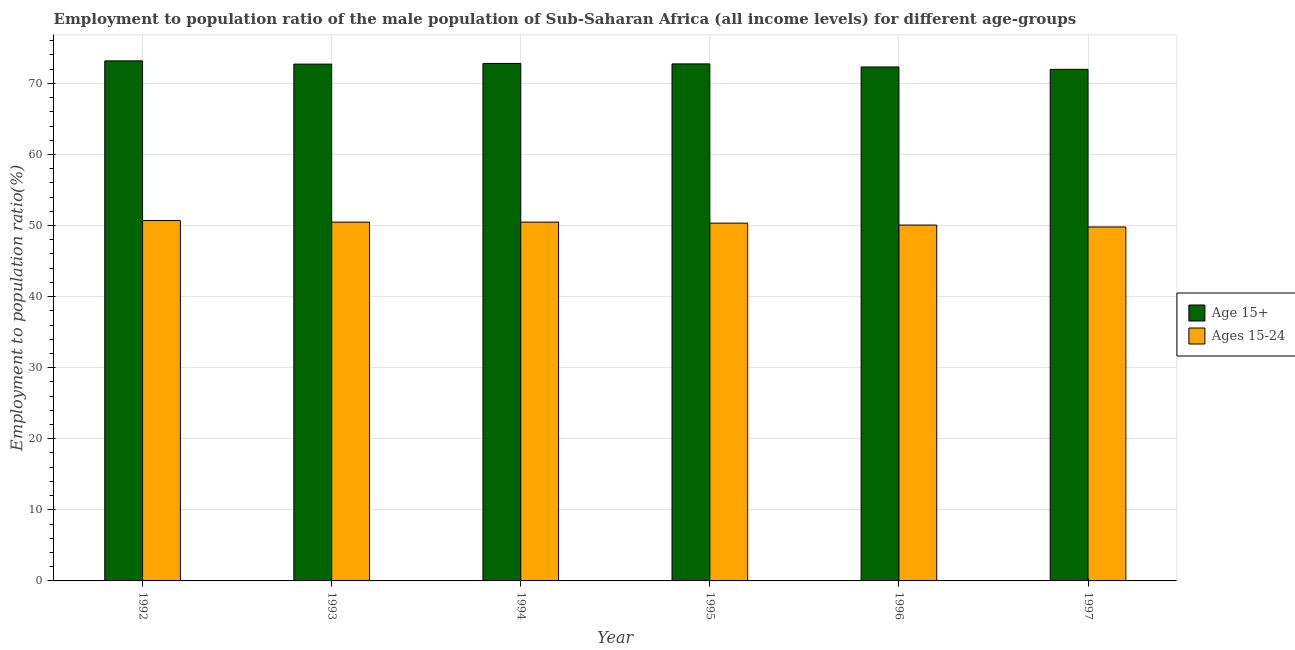How many different coloured bars are there?
Offer a terse response. 2. Are the number of bars on each tick of the X-axis equal?
Offer a very short reply. Yes. How many bars are there on the 6th tick from the right?
Offer a terse response. 2. What is the label of the 5th group of bars from the left?
Provide a succinct answer. 1996. In how many cases, is the number of bars for a given year not equal to the number of legend labels?
Keep it short and to the point. 0. What is the employment to population ratio(age 15+) in 1995?
Make the answer very short. 72.74. Across all years, what is the maximum employment to population ratio(age 15-24)?
Provide a succinct answer. 50.7. Across all years, what is the minimum employment to population ratio(age 15-24)?
Provide a succinct answer. 49.8. What is the total employment to population ratio(age 15+) in the graph?
Your answer should be very brief. 435.72. What is the difference between the employment to population ratio(age 15+) in 1994 and that in 1997?
Ensure brevity in your answer.  0.83. What is the difference between the employment to population ratio(age 15+) in 1993 and the employment to population ratio(age 15-24) in 1996?
Provide a short and direct response. 0.4. What is the average employment to population ratio(age 15-24) per year?
Your answer should be very brief. 50.31. What is the ratio of the employment to population ratio(age 15+) in 1993 to that in 1995?
Offer a very short reply. 1. What is the difference between the highest and the second highest employment to population ratio(age 15+)?
Your answer should be compact. 0.36. What is the difference between the highest and the lowest employment to population ratio(age 15-24)?
Your answer should be compact. 0.9. Is the sum of the employment to population ratio(age 15+) in 1992 and 1996 greater than the maximum employment to population ratio(age 15-24) across all years?
Your response must be concise. Yes. What does the 2nd bar from the left in 1994 represents?
Offer a terse response. Ages 15-24. What does the 2nd bar from the right in 1992 represents?
Your response must be concise. Age 15+. How many bars are there?
Keep it short and to the point. 12. How many years are there in the graph?
Offer a very short reply. 6. What is the difference between two consecutive major ticks on the Y-axis?
Keep it short and to the point. 10. Are the values on the major ticks of Y-axis written in scientific E-notation?
Offer a terse response. No. Where does the legend appear in the graph?
Make the answer very short. Center right. How many legend labels are there?
Your answer should be very brief. 2. What is the title of the graph?
Ensure brevity in your answer.  Employment to population ratio of the male population of Sub-Saharan Africa (all income levels) for different age-groups. Does "Commercial service exports" appear as one of the legend labels in the graph?
Offer a terse response. No. What is the label or title of the Y-axis?
Offer a terse response. Employment to population ratio(%). What is the Employment to population ratio(%) in Age 15+ in 1992?
Offer a very short reply. 73.17. What is the Employment to population ratio(%) in Ages 15-24 in 1992?
Offer a very short reply. 50.7. What is the Employment to population ratio(%) in Age 15+ in 1993?
Make the answer very short. 72.71. What is the Employment to population ratio(%) in Ages 15-24 in 1993?
Provide a succinct answer. 50.48. What is the Employment to population ratio(%) of Age 15+ in 1994?
Your answer should be compact. 72.81. What is the Employment to population ratio(%) of Ages 15-24 in 1994?
Ensure brevity in your answer.  50.48. What is the Employment to population ratio(%) in Age 15+ in 1995?
Give a very brief answer. 72.74. What is the Employment to population ratio(%) in Ages 15-24 in 1995?
Offer a very short reply. 50.34. What is the Employment to population ratio(%) of Age 15+ in 1996?
Your response must be concise. 72.31. What is the Employment to population ratio(%) of Ages 15-24 in 1996?
Make the answer very short. 50.07. What is the Employment to population ratio(%) in Age 15+ in 1997?
Give a very brief answer. 71.97. What is the Employment to population ratio(%) in Ages 15-24 in 1997?
Provide a succinct answer. 49.8. Across all years, what is the maximum Employment to population ratio(%) in Age 15+?
Offer a very short reply. 73.17. Across all years, what is the maximum Employment to population ratio(%) in Ages 15-24?
Offer a terse response. 50.7. Across all years, what is the minimum Employment to population ratio(%) in Age 15+?
Give a very brief answer. 71.97. Across all years, what is the minimum Employment to population ratio(%) in Ages 15-24?
Keep it short and to the point. 49.8. What is the total Employment to population ratio(%) of Age 15+ in the graph?
Your answer should be compact. 435.72. What is the total Employment to population ratio(%) in Ages 15-24 in the graph?
Provide a short and direct response. 301.88. What is the difference between the Employment to population ratio(%) in Age 15+ in 1992 and that in 1993?
Ensure brevity in your answer.  0.45. What is the difference between the Employment to population ratio(%) in Ages 15-24 in 1992 and that in 1993?
Give a very brief answer. 0.22. What is the difference between the Employment to population ratio(%) of Age 15+ in 1992 and that in 1994?
Offer a very short reply. 0.36. What is the difference between the Employment to population ratio(%) of Ages 15-24 in 1992 and that in 1994?
Offer a very short reply. 0.22. What is the difference between the Employment to population ratio(%) of Age 15+ in 1992 and that in 1995?
Give a very brief answer. 0.43. What is the difference between the Employment to population ratio(%) in Ages 15-24 in 1992 and that in 1995?
Make the answer very short. 0.36. What is the difference between the Employment to population ratio(%) of Age 15+ in 1992 and that in 1996?
Your answer should be compact. 0.86. What is the difference between the Employment to population ratio(%) in Ages 15-24 in 1992 and that in 1996?
Keep it short and to the point. 0.63. What is the difference between the Employment to population ratio(%) in Age 15+ in 1992 and that in 1997?
Offer a terse response. 1.19. What is the difference between the Employment to population ratio(%) of Ages 15-24 in 1992 and that in 1997?
Offer a terse response. 0.9. What is the difference between the Employment to population ratio(%) of Age 15+ in 1993 and that in 1994?
Ensure brevity in your answer.  -0.09. What is the difference between the Employment to population ratio(%) in Ages 15-24 in 1993 and that in 1994?
Ensure brevity in your answer.  -0. What is the difference between the Employment to population ratio(%) of Age 15+ in 1993 and that in 1995?
Provide a succinct answer. -0.03. What is the difference between the Employment to population ratio(%) of Ages 15-24 in 1993 and that in 1995?
Offer a very short reply. 0.14. What is the difference between the Employment to population ratio(%) in Age 15+ in 1993 and that in 1996?
Offer a very short reply. 0.4. What is the difference between the Employment to population ratio(%) in Ages 15-24 in 1993 and that in 1996?
Your answer should be compact. 0.41. What is the difference between the Employment to population ratio(%) of Age 15+ in 1993 and that in 1997?
Ensure brevity in your answer.  0.74. What is the difference between the Employment to population ratio(%) in Ages 15-24 in 1993 and that in 1997?
Your response must be concise. 0.68. What is the difference between the Employment to population ratio(%) of Age 15+ in 1994 and that in 1995?
Ensure brevity in your answer.  0.07. What is the difference between the Employment to population ratio(%) in Ages 15-24 in 1994 and that in 1995?
Offer a very short reply. 0.14. What is the difference between the Employment to population ratio(%) of Age 15+ in 1994 and that in 1996?
Your answer should be compact. 0.5. What is the difference between the Employment to population ratio(%) of Ages 15-24 in 1994 and that in 1996?
Your response must be concise. 0.41. What is the difference between the Employment to population ratio(%) in Age 15+ in 1994 and that in 1997?
Provide a short and direct response. 0.83. What is the difference between the Employment to population ratio(%) in Ages 15-24 in 1994 and that in 1997?
Offer a terse response. 0.68. What is the difference between the Employment to population ratio(%) of Age 15+ in 1995 and that in 1996?
Make the answer very short. 0.43. What is the difference between the Employment to population ratio(%) in Ages 15-24 in 1995 and that in 1996?
Ensure brevity in your answer.  0.27. What is the difference between the Employment to population ratio(%) of Age 15+ in 1995 and that in 1997?
Your answer should be compact. 0.77. What is the difference between the Employment to population ratio(%) in Ages 15-24 in 1995 and that in 1997?
Keep it short and to the point. 0.54. What is the difference between the Employment to population ratio(%) in Age 15+ in 1996 and that in 1997?
Your answer should be very brief. 0.34. What is the difference between the Employment to population ratio(%) in Ages 15-24 in 1996 and that in 1997?
Offer a terse response. 0.27. What is the difference between the Employment to population ratio(%) of Age 15+ in 1992 and the Employment to population ratio(%) of Ages 15-24 in 1993?
Give a very brief answer. 22.69. What is the difference between the Employment to population ratio(%) in Age 15+ in 1992 and the Employment to population ratio(%) in Ages 15-24 in 1994?
Make the answer very short. 22.69. What is the difference between the Employment to population ratio(%) in Age 15+ in 1992 and the Employment to population ratio(%) in Ages 15-24 in 1995?
Your answer should be compact. 22.83. What is the difference between the Employment to population ratio(%) of Age 15+ in 1992 and the Employment to population ratio(%) of Ages 15-24 in 1996?
Offer a very short reply. 23.1. What is the difference between the Employment to population ratio(%) of Age 15+ in 1992 and the Employment to population ratio(%) of Ages 15-24 in 1997?
Offer a very short reply. 23.37. What is the difference between the Employment to population ratio(%) in Age 15+ in 1993 and the Employment to population ratio(%) in Ages 15-24 in 1994?
Offer a terse response. 22.23. What is the difference between the Employment to population ratio(%) of Age 15+ in 1993 and the Employment to population ratio(%) of Ages 15-24 in 1995?
Ensure brevity in your answer.  22.37. What is the difference between the Employment to population ratio(%) in Age 15+ in 1993 and the Employment to population ratio(%) in Ages 15-24 in 1996?
Provide a short and direct response. 22.64. What is the difference between the Employment to population ratio(%) in Age 15+ in 1993 and the Employment to population ratio(%) in Ages 15-24 in 1997?
Give a very brief answer. 22.91. What is the difference between the Employment to population ratio(%) of Age 15+ in 1994 and the Employment to population ratio(%) of Ages 15-24 in 1995?
Give a very brief answer. 22.47. What is the difference between the Employment to population ratio(%) of Age 15+ in 1994 and the Employment to population ratio(%) of Ages 15-24 in 1996?
Keep it short and to the point. 22.74. What is the difference between the Employment to population ratio(%) of Age 15+ in 1994 and the Employment to population ratio(%) of Ages 15-24 in 1997?
Keep it short and to the point. 23.01. What is the difference between the Employment to population ratio(%) of Age 15+ in 1995 and the Employment to population ratio(%) of Ages 15-24 in 1996?
Provide a short and direct response. 22.67. What is the difference between the Employment to population ratio(%) in Age 15+ in 1995 and the Employment to population ratio(%) in Ages 15-24 in 1997?
Keep it short and to the point. 22.94. What is the difference between the Employment to population ratio(%) of Age 15+ in 1996 and the Employment to population ratio(%) of Ages 15-24 in 1997?
Make the answer very short. 22.51. What is the average Employment to population ratio(%) in Age 15+ per year?
Provide a succinct answer. 72.62. What is the average Employment to population ratio(%) of Ages 15-24 per year?
Offer a very short reply. 50.31. In the year 1992, what is the difference between the Employment to population ratio(%) of Age 15+ and Employment to population ratio(%) of Ages 15-24?
Keep it short and to the point. 22.47. In the year 1993, what is the difference between the Employment to population ratio(%) in Age 15+ and Employment to population ratio(%) in Ages 15-24?
Offer a very short reply. 22.23. In the year 1994, what is the difference between the Employment to population ratio(%) of Age 15+ and Employment to population ratio(%) of Ages 15-24?
Give a very brief answer. 22.33. In the year 1995, what is the difference between the Employment to population ratio(%) of Age 15+ and Employment to population ratio(%) of Ages 15-24?
Make the answer very short. 22.4. In the year 1996, what is the difference between the Employment to population ratio(%) of Age 15+ and Employment to population ratio(%) of Ages 15-24?
Keep it short and to the point. 22.24. In the year 1997, what is the difference between the Employment to population ratio(%) of Age 15+ and Employment to population ratio(%) of Ages 15-24?
Provide a succinct answer. 22.17. What is the ratio of the Employment to population ratio(%) in Ages 15-24 in 1992 to that in 1994?
Provide a short and direct response. 1. What is the ratio of the Employment to population ratio(%) of Age 15+ in 1992 to that in 1995?
Your response must be concise. 1.01. What is the ratio of the Employment to population ratio(%) in Ages 15-24 in 1992 to that in 1995?
Offer a terse response. 1.01. What is the ratio of the Employment to population ratio(%) of Age 15+ in 1992 to that in 1996?
Offer a very short reply. 1.01. What is the ratio of the Employment to population ratio(%) in Ages 15-24 in 1992 to that in 1996?
Ensure brevity in your answer.  1.01. What is the ratio of the Employment to population ratio(%) of Age 15+ in 1992 to that in 1997?
Provide a short and direct response. 1.02. What is the ratio of the Employment to population ratio(%) of Age 15+ in 1993 to that in 1994?
Offer a terse response. 1. What is the ratio of the Employment to population ratio(%) in Ages 15-24 in 1993 to that in 1994?
Keep it short and to the point. 1. What is the ratio of the Employment to population ratio(%) of Ages 15-24 in 1993 to that in 1995?
Your response must be concise. 1. What is the ratio of the Employment to population ratio(%) in Age 15+ in 1993 to that in 1996?
Offer a very short reply. 1.01. What is the ratio of the Employment to population ratio(%) of Ages 15-24 in 1993 to that in 1996?
Your answer should be very brief. 1.01. What is the ratio of the Employment to population ratio(%) of Age 15+ in 1993 to that in 1997?
Your answer should be compact. 1.01. What is the ratio of the Employment to population ratio(%) in Ages 15-24 in 1993 to that in 1997?
Offer a very short reply. 1.01. What is the ratio of the Employment to population ratio(%) of Ages 15-24 in 1994 to that in 1995?
Provide a short and direct response. 1. What is the ratio of the Employment to population ratio(%) of Ages 15-24 in 1994 to that in 1996?
Provide a succinct answer. 1.01. What is the ratio of the Employment to population ratio(%) of Age 15+ in 1994 to that in 1997?
Keep it short and to the point. 1.01. What is the ratio of the Employment to population ratio(%) in Ages 15-24 in 1994 to that in 1997?
Provide a succinct answer. 1.01. What is the ratio of the Employment to population ratio(%) in Ages 15-24 in 1995 to that in 1996?
Provide a succinct answer. 1.01. What is the ratio of the Employment to population ratio(%) in Age 15+ in 1995 to that in 1997?
Provide a succinct answer. 1.01. What is the ratio of the Employment to population ratio(%) of Ages 15-24 in 1995 to that in 1997?
Your response must be concise. 1.01. What is the ratio of the Employment to population ratio(%) in Ages 15-24 in 1996 to that in 1997?
Offer a very short reply. 1.01. What is the difference between the highest and the second highest Employment to population ratio(%) in Age 15+?
Ensure brevity in your answer.  0.36. What is the difference between the highest and the second highest Employment to population ratio(%) of Ages 15-24?
Keep it short and to the point. 0.22. What is the difference between the highest and the lowest Employment to population ratio(%) in Age 15+?
Provide a succinct answer. 1.19. What is the difference between the highest and the lowest Employment to population ratio(%) in Ages 15-24?
Your answer should be very brief. 0.9. 